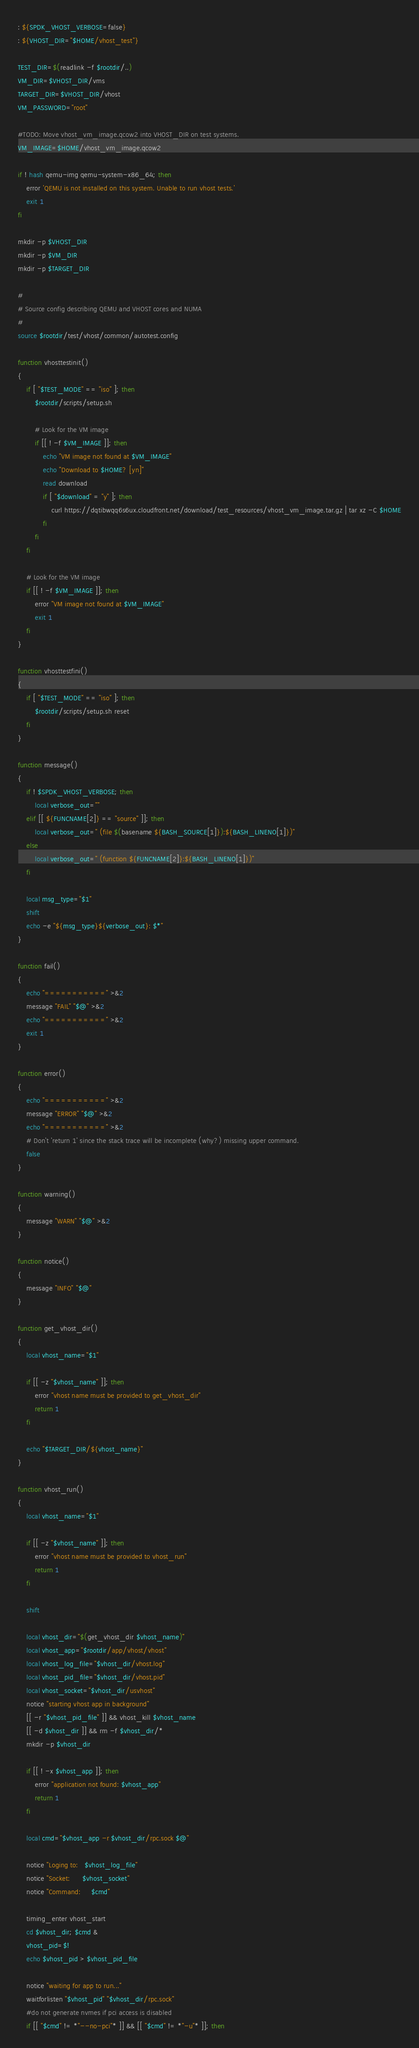<code> <loc_0><loc_0><loc_500><loc_500><_Bash_>: ${SPDK_VHOST_VERBOSE=false}
: ${VHOST_DIR="$HOME/vhost_test"}

TEST_DIR=$(readlink -f $rootdir/..)
VM_DIR=$VHOST_DIR/vms
TARGET_DIR=$VHOST_DIR/vhost
VM_PASSWORD="root"

#TODO: Move vhost_vm_image.qcow2 into VHOST_DIR on test systems.
VM_IMAGE=$HOME/vhost_vm_image.qcow2

if ! hash qemu-img qemu-system-x86_64; then
	error 'QEMU is not installed on this system. Unable to run vhost tests.'
	exit 1
fi

mkdir -p $VHOST_DIR
mkdir -p $VM_DIR
mkdir -p $TARGET_DIR

#
# Source config describing QEMU and VHOST cores and NUMA
#
source $rootdir/test/vhost/common/autotest.config

function vhosttestinit()
{
	if [ "$TEST_MODE" == "iso" ]; then
		$rootdir/scripts/setup.sh

		# Look for the VM image
		if [[ ! -f $VM_IMAGE ]]; then
			echo "VM image not found at $VM_IMAGE"
			echo "Download to $HOME? [yn]"
			read download
			if [ "$download" = "y" ]; then
				curl https://dqtibwqq6s6ux.cloudfront.net/download/test_resources/vhost_vm_image.tar.gz | tar xz -C $HOME
			fi
		fi
	fi

	# Look for the VM image
	if [[ ! -f $VM_IMAGE ]]; then
		error "VM image not found at $VM_IMAGE"
		exit 1
	fi
}

function vhosttestfini()
{
	if [ "$TEST_MODE" == "iso" ]; then
		$rootdir/scripts/setup.sh reset
	fi
}

function message()
{
	if ! $SPDK_VHOST_VERBOSE; then
		local verbose_out=""
	elif [[ ${FUNCNAME[2]} == "source" ]]; then
		local verbose_out=" (file $(basename ${BASH_SOURCE[1]}):${BASH_LINENO[1]})"
	else
		local verbose_out=" (function ${FUNCNAME[2]}:${BASH_LINENO[1]})"
	fi

	local msg_type="$1"
	shift
	echo -e "${msg_type}${verbose_out}: $*"
}

function fail()
{
	echo "===========" >&2
	message "FAIL" "$@" >&2
	echo "===========" >&2
	exit 1
}

function error()
{
	echo "===========" >&2
	message "ERROR" "$@" >&2
	echo "===========" >&2
	# Don't 'return 1' since the stack trace will be incomplete (why?) missing upper command.
	false
}

function warning()
{
	message "WARN" "$@" >&2
}

function notice()
{
	message "INFO" "$@"
}

function get_vhost_dir()
{
	local vhost_name="$1"

	if [[ -z "$vhost_name" ]]; then
		error "vhost name must be provided to get_vhost_dir"
		return 1
	fi

	echo "$TARGET_DIR/${vhost_name}"
}

function vhost_run()
{
	local vhost_name="$1"

	if [[ -z "$vhost_name" ]]; then
		error "vhost name must be provided to vhost_run"
		return 1
	fi

	shift

	local vhost_dir="$(get_vhost_dir $vhost_name)"
	local vhost_app="$rootdir/app/vhost/vhost"
	local vhost_log_file="$vhost_dir/vhost.log"
	local vhost_pid_file="$vhost_dir/vhost.pid"
	local vhost_socket="$vhost_dir/usvhost"
	notice "starting vhost app in background"
	[[ -r "$vhost_pid_file" ]] && vhost_kill $vhost_name
	[[ -d $vhost_dir ]] && rm -f $vhost_dir/*
	mkdir -p $vhost_dir

	if [[ ! -x $vhost_app ]]; then
		error "application not found: $vhost_app"
		return 1
	fi

	local cmd="$vhost_app -r $vhost_dir/rpc.sock $@"

	notice "Loging to:   $vhost_log_file"
	notice "Socket:      $vhost_socket"
	notice "Command:     $cmd"

	timing_enter vhost_start
	cd $vhost_dir; $cmd &
	vhost_pid=$!
	echo $vhost_pid > $vhost_pid_file

	notice "waiting for app to run..."
	waitforlisten "$vhost_pid" "$vhost_dir/rpc.sock"
	#do not generate nvmes if pci access is disabled
	if [[ "$cmd" != *"--no-pci"* ]] && [[ "$cmd" != *"-u"* ]]; then</code> 